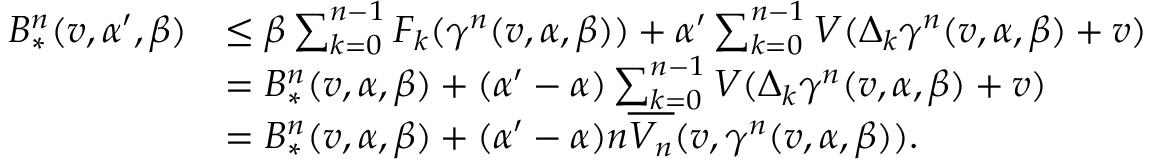Convert formula to latex. <formula><loc_0><loc_0><loc_500><loc_500>\begin{array} { r l } { B _ { * } ^ { n } ( v , \alpha ^ { \prime } , \beta ) } & { \leq \beta \sum _ { k = 0 } ^ { n - 1 } F _ { k } ( \gamma ^ { n } ( v , \alpha , \beta ) ) + \alpha ^ { \prime } \sum _ { k = 0 } ^ { n - 1 } V ( \Delta _ { k } \gamma ^ { n } ( v , \alpha , \beta ) + v ) } \\ & { = B _ { * } ^ { n } ( v , \alpha , \beta ) + ( \alpha ^ { \prime } - \alpha ) \sum _ { k = 0 } ^ { n - 1 } V ( \Delta _ { k } \gamma ^ { n } ( v , \alpha , \beta ) + v ) } \\ & { = B _ { * } ^ { n } ( v , \alpha , \beta ) + ( \alpha ^ { \prime } - \alpha ) n \overline { { V _ { n } } } ( v , \gamma ^ { n } ( v , \alpha , \beta ) ) . } \end{array}</formula> 